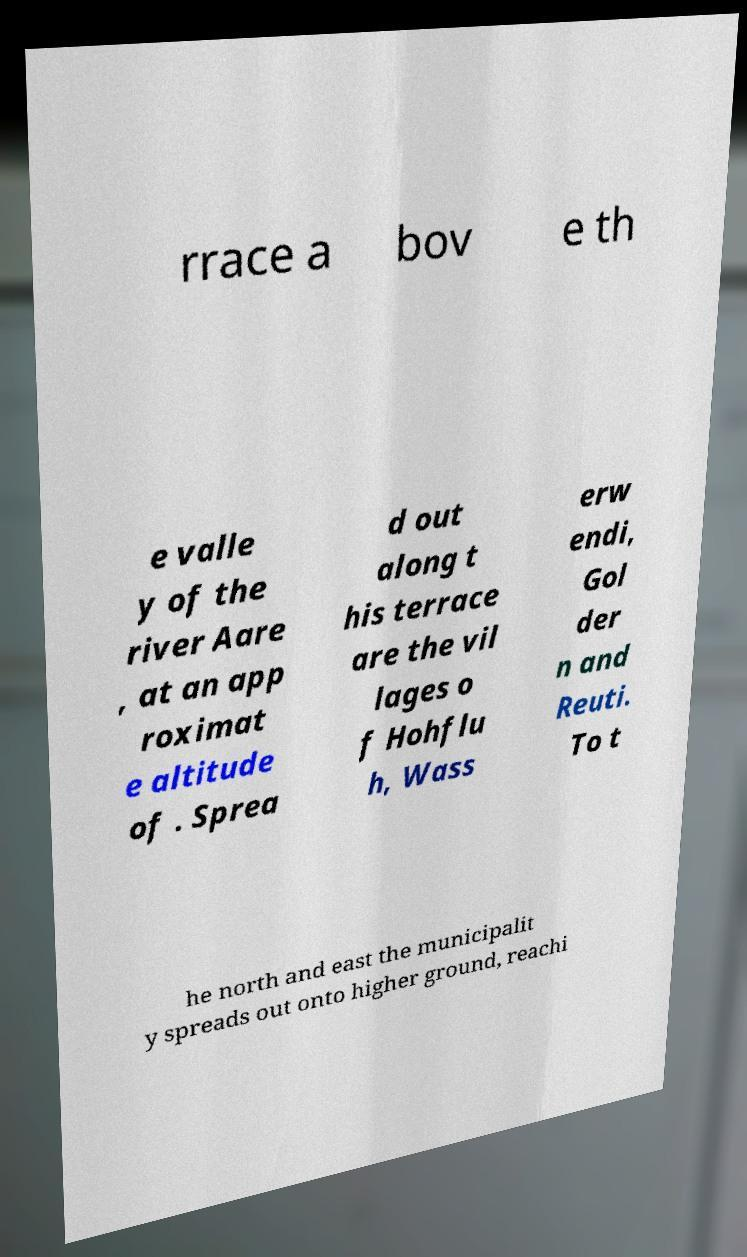Please identify and transcribe the text found in this image. rrace a bov e th e valle y of the river Aare , at an app roximat e altitude of . Sprea d out along t his terrace are the vil lages o f Hohflu h, Wass erw endi, Gol der n and Reuti. To t he north and east the municipalit y spreads out onto higher ground, reachi 